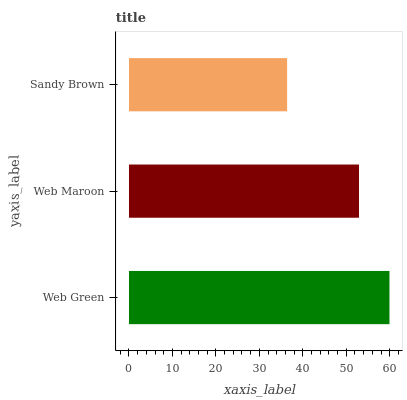Is Sandy Brown the minimum?
Answer yes or no. Yes. Is Web Green the maximum?
Answer yes or no. Yes. Is Web Maroon the minimum?
Answer yes or no. No. Is Web Maroon the maximum?
Answer yes or no. No. Is Web Green greater than Web Maroon?
Answer yes or no. Yes. Is Web Maroon less than Web Green?
Answer yes or no. Yes. Is Web Maroon greater than Web Green?
Answer yes or no. No. Is Web Green less than Web Maroon?
Answer yes or no. No. Is Web Maroon the high median?
Answer yes or no. Yes. Is Web Maroon the low median?
Answer yes or no. Yes. Is Sandy Brown the high median?
Answer yes or no. No. Is Sandy Brown the low median?
Answer yes or no. No. 